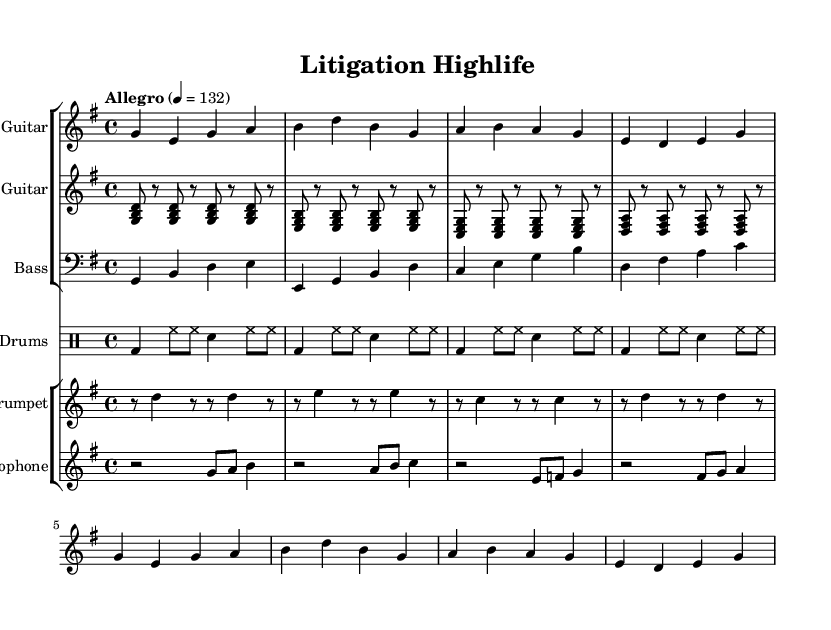What is the key signature of this music? The key signature is G major, which features one sharp (F#). This can be identified by looking at the key signature indicated at the beginning of the sheet music.
Answer: G major What is the time signature of this music? The time signature is 4/4, meaning there are four beats in each measure and a quarter note receives one beat. This is indicated at the beginning of the score after the key signature.
Answer: 4/4 What is the tempo marking for this piece? The tempo marking is "Allegro," which indicates a fast and lively tempo. The numerical marking "4 = 132" signifies that there are 132 beats per minute. Both of these can be found in the header section of the sheet music.
Answer: Allegro How many instruments are featured in this score? There are five distinct instrumental parts in this score: Lead Guitar, Rhythm Guitar, Bass, Drums, Trumpet, and Saxophone. Each of these parts is shown in separate staves, making it easy to count them.
Answer: Five Which instrument plays the melody primarily in this highlife piece? The Lead Guitar predominantly plays the melody, as indicated by the first staff's notation and the way it’s labeled as "Lead Guitar." The melodic line is typically assigned to this instrument in highlife music.
Answer: Lead Guitar What rhythmic pattern does the drums primarily use? The drums primarily use a bass drum on beats 1 and 3, and hi-hat on all eighth notes along with a snare hit on beats 2 and 4. This rhythmic pattern can be observed through the notation in the drum part.
Answer: Bass-Snare-Hihat 